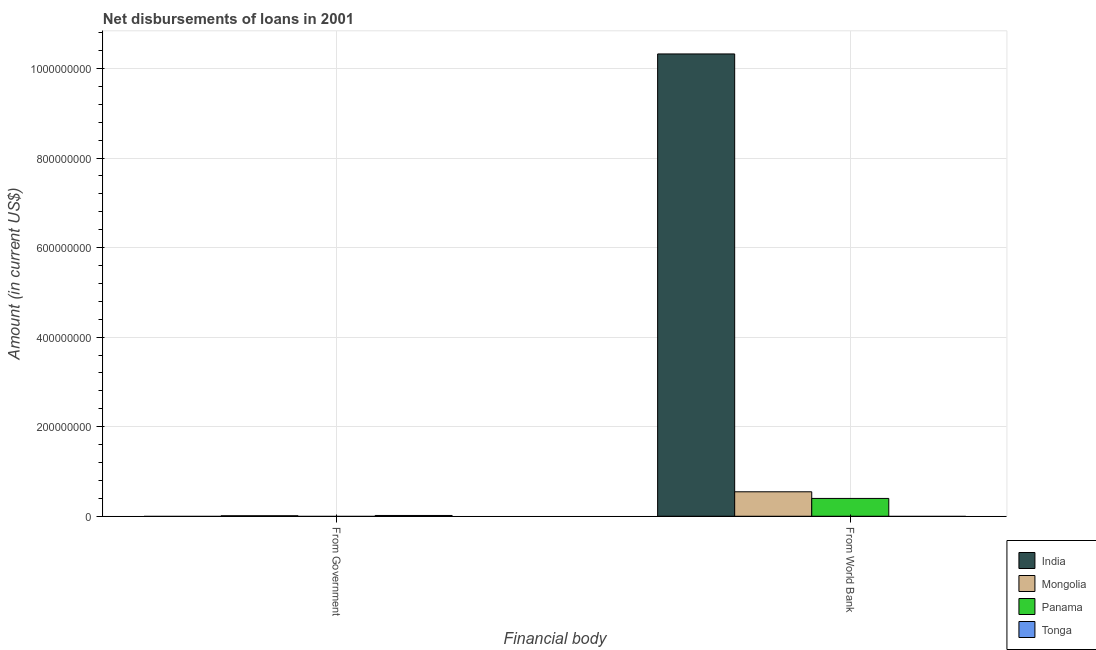Are the number of bars on each tick of the X-axis equal?
Provide a short and direct response. No. How many bars are there on the 2nd tick from the left?
Provide a succinct answer. 3. What is the label of the 1st group of bars from the left?
Offer a very short reply. From Government. What is the net disbursements of loan from government in Tonga?
Offer a terse response. 1.72e+06. Across all countries, what is the maximum net disbursements of loan from world bank?
Your response must be concise. 1.03e+09. Across all countries, what is the minimum net disbursements of loan from world bank?
Provide a short and direct response. 0. In which country was the net disbursements of loan from world bank maximum?
Your answer should be very brief. India. What is the total net disbursements of loan from government in the graph?
Give a very brief answer. 2.83e+06. What is the difference between the net disbursements of loan from government in Tonga and that in Mongolia?
Provide a succinct answer. 6.06e+05. What is the difference between the net disbursements of loan from world bank in Panama and the net disbursements of loan from government in Mongolia?
Offer a terse response. 3.87e+07. What is the average net disbursements of loan from world bank per country?
Make the answer very short. 2.82e+08. In how many countries, is the net disbursements of loan from government greater than the average net disbursements of loan from government taken over all countries?
Keep it short and to the point. 2. How many bars are there?
Keep it short and to the point. 5. How many countries are there in the graph?
Provide a succinct answer. 4. What is the difference between two consecutive major ticks on the Y-axis?
Your answer should be compact. 2.00e+08. Where does the legend appear in the graph?
Your answer should be compact. Bottom right. How are the legend labels stacked?
Provide a short and direct response. Vertical. What is the title of the graph?
Ensure brevity in your answer.  Net disbursements of loans in 2001. Does "Canada" appear as one of the legend labels in the graph?
Make the answer very short. No. What is the label or title of the X-axis?
Your answer should be very brief. Financial body. What is the Amount (in current US$) of India in From Government?
Keep it short and to the point. 0. What is the Amount (in current US$) in Mongolia in From Government?
Offer a terse response. 1.11e+06. What is the Amount (in current US$) of Panama in From Government?
Make the answer very short. 0. What is the Amount (in current US$) in Tonga in From Government?
Provide a short and direct response. 1.72e+06. What is the Amount (in current US$) in India in From World Bank?
Keep it short and to the point. 1.03e+09. What is the Amount (in current US$) in Mongolia in From World Bank?
Ensure brevity in your answer.  5.46e+07. What is the Amount (in current US$) in Panama in From World Bank?
Offer a terse response. 3.98e+07. What is the Amount (in current US$) in Tonga in From World Bank?
Keep it short and to the point. 0. Across all Financial body, what is the maximum Amount (in current US$) in India?
Your answer should be very brief. 1.03e+09. Across all Financial body, what is the maximum Amount (in current US$) of Mongolia?
Ensure brevity in your answer.  5.46e+07. Across all Financial body, what is the maximum Amount (in current US$) in Panama?
Provide a succinct answer. 3.98e+07. Across all Financial body, what is the maximum Amount (in current US$) in Tonga?
Make the answer very short. 1.72e+06. Across all Financial body, what is the minimum Amount (in current US$) in Mongolia?
Keep it short and to the point. 1.11e+06. What is the total Amount (in current US$) of India in the graph?
Ensure brevity in your answer.  1.03e+09. What is the total Amount (in current US$) in Mongolia in the graph?
Your answer should be compact. 5.57e+07. What is the total Amount (in current US$) of Panama in the graph?
Ensure brevity in your answer.  3.98e+07. What is the total Amount (in current US$) in Tonga in the graph?
Your answer should be very brief. 1.72e+06. What is the difference between the Amount (in current US$) of Mongolia in From Government and that in From World Bank?
Keep it short and to the point. -5.35e+07. What is the difference between the Amount (in current US$) of Mongolia in From Government and the Amount (in current US$) of Panama in From World Bank?
Your answer should be compact. -3.87e+07. What is the average Amount (in current US$) of India per Financial body?
Ensure brevity in your answer.  5.16e+08. What is the average Amount (in current US$) of Mongolia per Financial body?
Ensure brevity in your answer.  2.79e+07. What is the average Amount (in current US$) in Panama per Financial body?
Your answer should be compact. 1.99e+07. What is the average Amount (in current US$) of Tonga per Financial body?
Your answer should be compact. 8.60e+05. What is the difference between the Amount (in current US$) of Mongolia and Amount (in current US$) of Tonga in From Government?
Your response must be concise. -6.06e+05. What is the difference between the Amount (in current US$) in India and Amount (in current US$) in Mongolia in From World Bank?
Keep it short and to the point. 9.78e+08. What is the difference between the Amount (in current US$) in India and Amount (in current US$) in Panama in From World Bank?
Make the answer very short. 9.93e+08. What is the difference between the Amount (in current US$) of Mongolia and Amount (in current US$) of Panama in From World Bank?
Make the answer very short. 1.48e+07. What is the ratio of the Amount (in current US$) of Mongolia in From Government to that in From World Bank?
Your response must be concise. 0.02. What is the difference between the highest and the second highest Amount (in current US$) of Mongolia?
Offer a very short reply. 5.35e+07. What is the difference between the highest and the lowest Amount (in current US$) in India?
Provide a short and direct response. 1.03e+09. What is the difference between the highest and the lowest Amount (in current US$) in Mongolia?
Ensure brevity in your answer.  5.35e+07. What is the difference between the highest and the lowest Amount (in current US$) in Panama?
Your answer should be compact. 3.98e+07. What is the difference between the highest and the lowest Amount (in current US$) of Tonga?
Your answer should be very brief. 1.72e+06. 